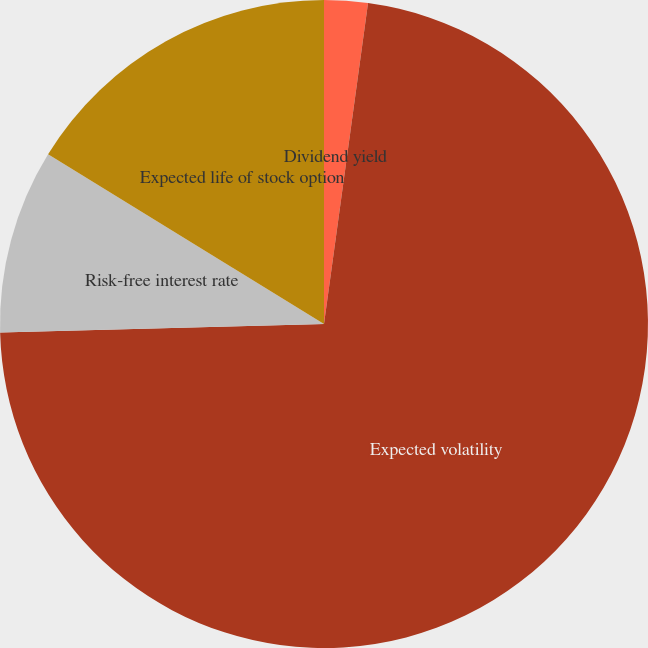Convert chart to OTSL. <chart><loc_0><loc_0><loc_500><loc_500><pie_chart><fcel>Dividend yield<fcel>Expected volatility<fcel>Risk-free interest rate<fcel>Expected life of stock option<nl><fcel>2.17%<fcel>72.41%<fcel>9.2%<fcel>16.22%<nl></chart> 